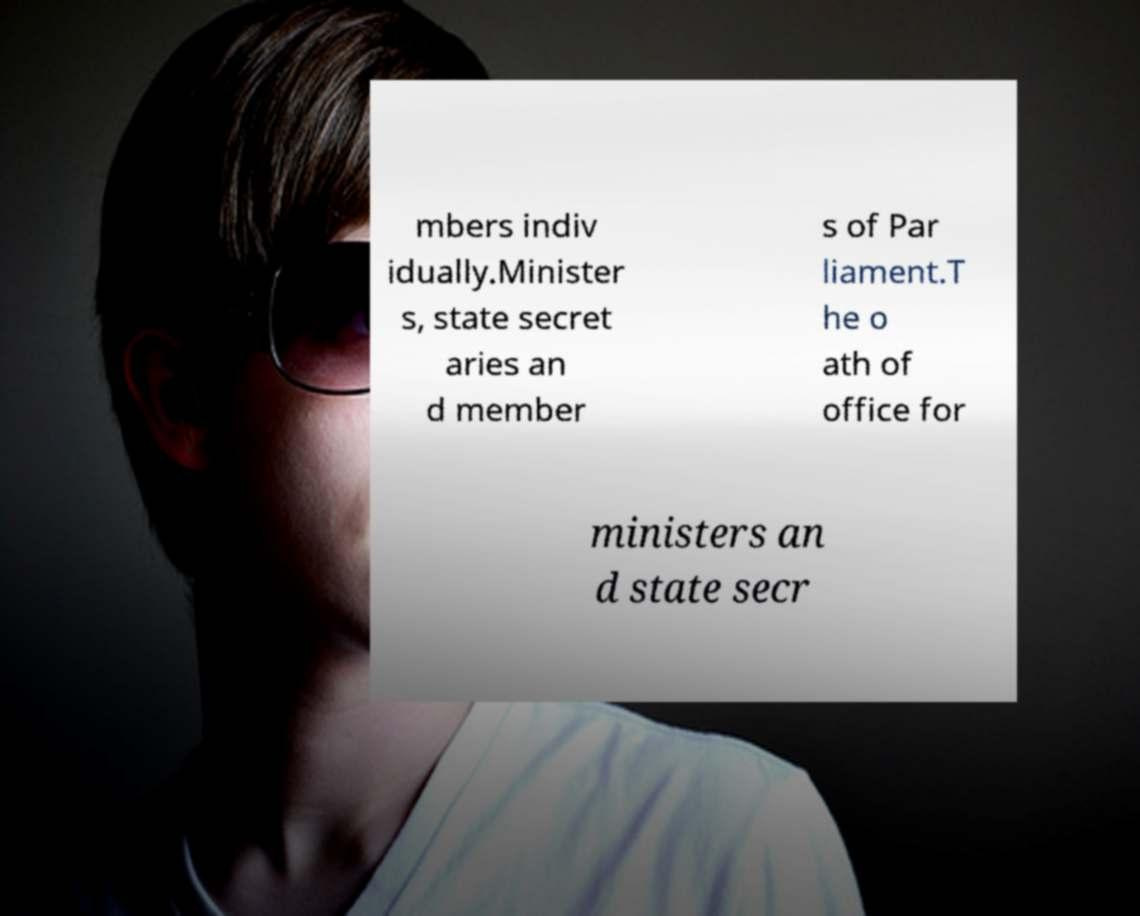For documentation purposes, I need the text within this image transcribed. Could you provide that? mbers indiv idually.Minister s, state secret aries an d member s of Par liament.T he o ath of office for ministers an d state secr 